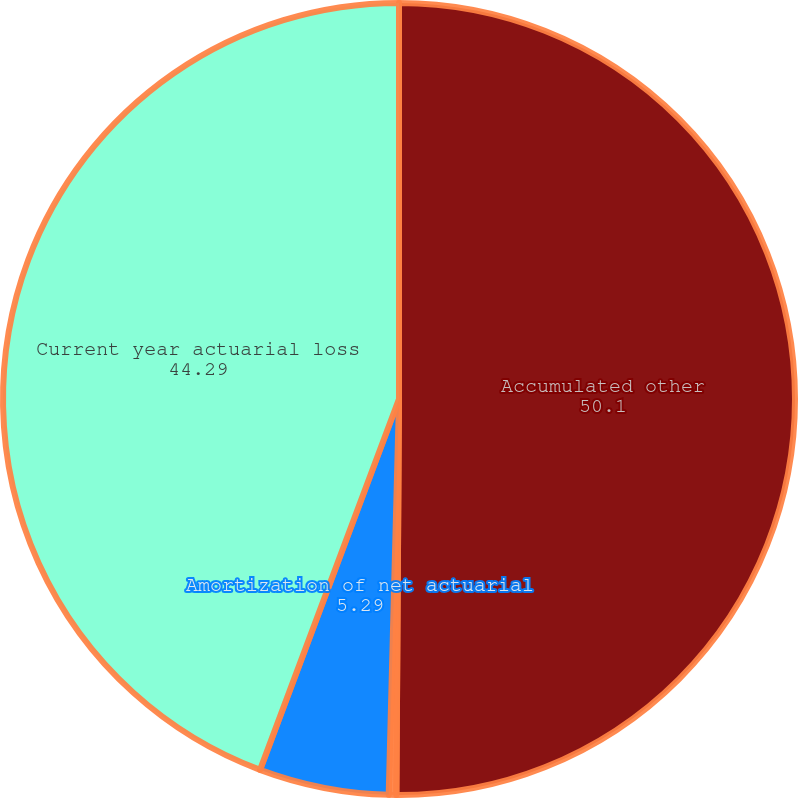Convert chart to OTSL. <chart><loc_0><loc_0><loc_500><loc_500><pie_chart><fcel>Accumulated other<fcel>Amortization of prior service<fcel>Amortization of net actuarial<fcel>Current year actuarial loss<nl><fcel>50.1%<fcel>0.31%<fcel>5.29%<fcel>44.29%<nl></chart> 